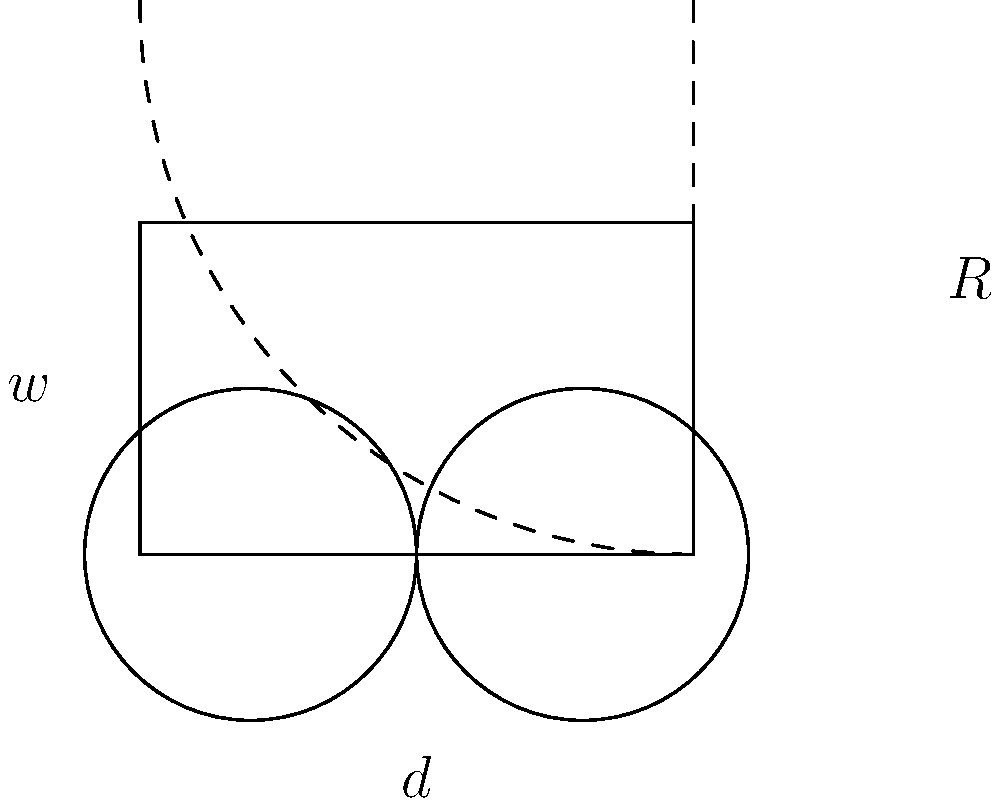A wheelchair has a wheel base ($w$) of 24 inches and a wheel diameter ($d$) of 24 inches. Calculate the minimum turning radius ($R$) of the wheelchair, assuming it can pivot around one stationary rear wheel. Round your answer to the nearest inch. To calculate the minimum turning radius of a wheelchair, we can use the following steps:

1) The turning radius is measured from the center of rotation (the stationary wheel) to the furthest point on the wheelchair (the opposite front corner).

2) This forms a right triangle where:
   - The hypotenuse is the turning radius ($R$)
   - One leg is the wheel base ($w$)
   - The other leg is half the wheel base plus the wheel radius ($\frac{w}{2} + \frac{d}{2}$)

3) We can use the Pythagorean theorem to find $R$:

   $$R^2 = w^2 + (\frac{w}{2} + \frac{d}{2})^2$$

4) Substituting the given values:
   $w = 24$ inches
   $d = 24$ inches

   $$R^2 = 24^2 + (12 + 12)^2$$
   $$R^2 = 576 + 576 = 1152$$

5) Taking the square root of both sides:

   $$R = \sqrt{1152} \approx 33.94$$

6) Rounding to the nearest inch:

   $R \approx 34$ inches
Answer: 34 inches 